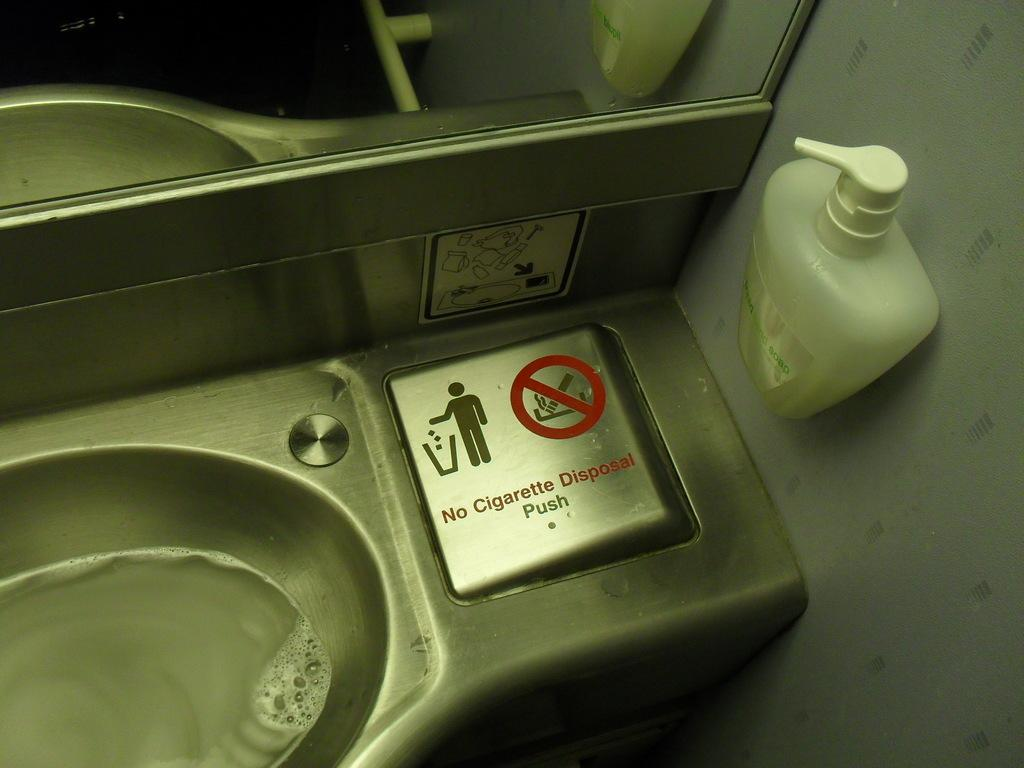What can be found in the image that is typically used for washing hands? There is a sink in the image that is typically used for washing hands. What is located above the sink in the image? There is a mirror above the sink in the image. What item is placed beside the mirror in the image? There is a hand wash bottle beside the mirror in the image. What is the mass of the mirror in the image? The mass of the mirror cannot be determined from the image alone, as it requires additional information or tools to measure. 